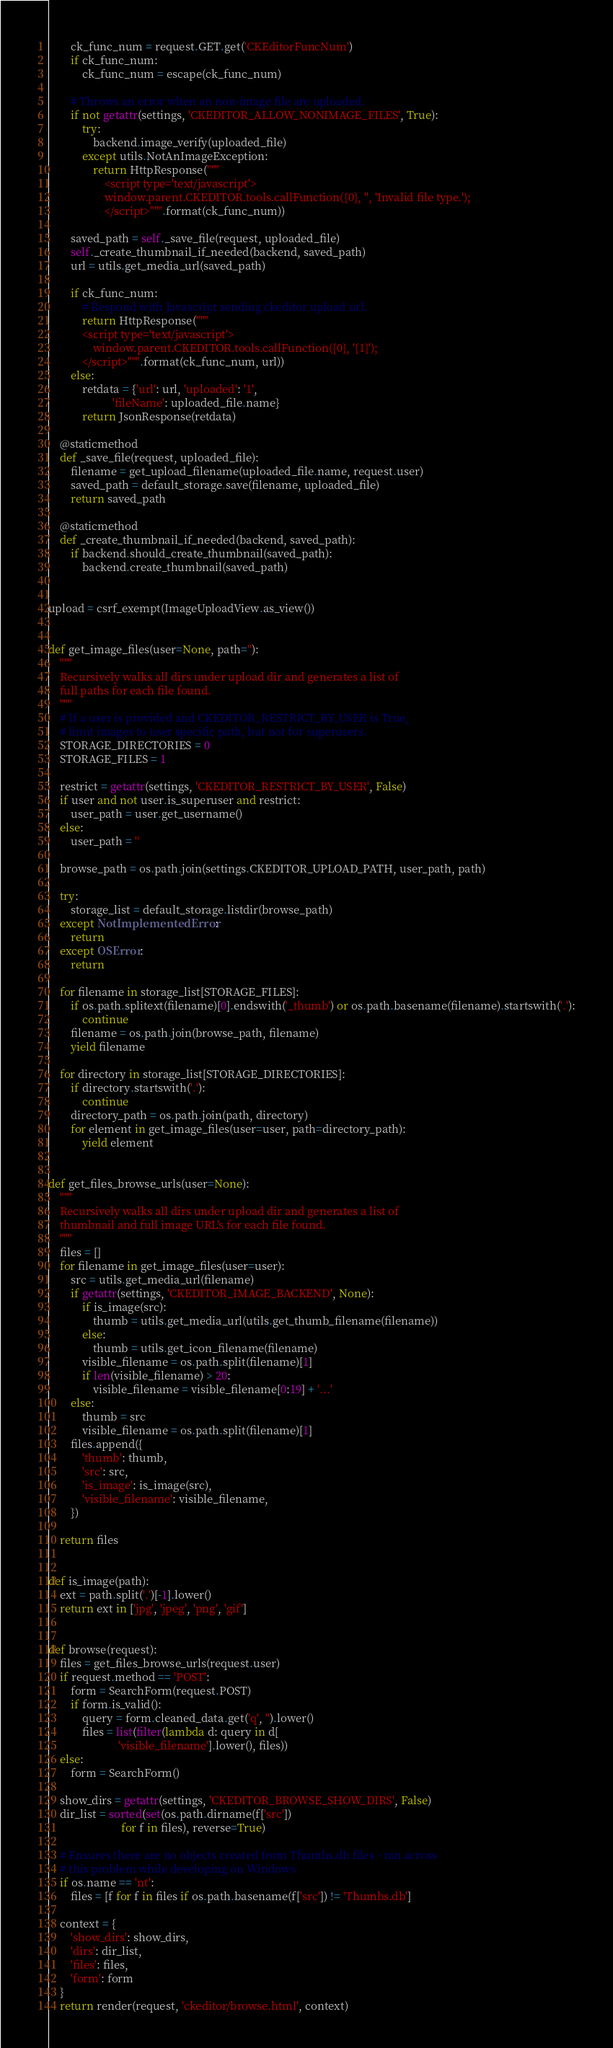Convert code to text. <code><loc_0><loc_0><loc_500><loc_500><_Python_>
        ck_func_num = request.GET.get('CKEditorFuncNum')
        if ck_func_num:
            ck_func_num = escape(ck_func_num)

        # Throws an error when an non-image file are uploaded.
        if not getattr(settings, 'CKEDITOR_ALLOW_NONIMAGE_FILES', True):
            try:
                backend.image_verify(uploaded_file)
            except utils.NotAnImageException:
                return HttpResponse("""
                    <script type='text/javascript'>
                    window.parent.CKEDITOR.tools.callFunction({0}, '', 'Invalid file type.');
                    </script>""".format(ck_func_num))

        saved_path = self._save_file(request, uploaded_file)
        self._create_thumbnail_if_needed(backend, saved_path)
        url = utils.get_media_url(saved_path)

        if ck_func_num:
            # Respond with Javascript sending ckeditor upload url.
            return HttpResponse("""
            <script type='text/javascript'>
                window.parent.CKEDITOR.tools.callFunction({0}, '{1}');
            </script>""".format(ck_func_num, url))
        else:
            retdata = {'url': url, 'uploaded': '1',
                       'fileName': uploaded_file.name}
            return JsonResponse(retdata)

    @staticmethod
    def _save_file(request, uploaded_file):
        filename = get_upload_filename(uploaded_file.name, request.user)
        saved_path = default_storage.save(filename, uploaded_file)
        return saved_path

    @staticmethod
    def _create_thumbnail_if_needed(backend, saved_path):
        if backend.should_create_thumbnail(saved_path):
            backend.create_thumbnail(saved_path)


upload = csrf_exempt(ImageUploadView.as_view())


def get_image_files(user=None, path=''):
    """
    Recursively walks all dirs under upload dir and generates a list of
    full paths for each file found.
    """
    # If a user is provided and CKEDITOR_RESTRICT_BY_USER is True,
    # limit images to user specific path, but not for superusers.
    STORAGE_DIRECTORIES = 0
    STORAGE_FILES = 1

    restrict = getattr(settings, 'CKEDITOR_RESTRICT_BY_USER', False)
    if user and not user.is_superuser and restrict:
        user_path = user.get_username()
    else:
        user_path = ''

    browse_path = os.path.join(settings.CKEDITOR_UPLOAD_PATH, user_path, path)

    try:
        storage_list = default_storage.listdir(browse_path)
    except NotImplementedError:
        return
    except OSError:
        return

    for filename in storage_list[STORAGE_FILES]:
        if os.path.splitext(filename)[0].endswith('_thumb') or os.path.basename(filename).startswith('.'):
            continue
        filename = os.path.join(browse_path, filename)
        yield filename

    for directory in storage_list[STORAGE_DIRECTORIES]:
        if directory.startswith('.'):
            continue
        directory_path = os.path.join(path, directory)
        for element in get_image_files(user=user, path=directory_path):
            yield element


def get_files_browse_urls(user=None):
    """
    Recursively walks all dirs under upload dir and generates a list of
    thumbnail and full image URL's for each file found.
    """
    files = []
    for filename in get_image_files(user=user):
        src = utils.get_media_url(filename)
        if getattr(settings, 'CKEDITOR_IMAGE_BACKEND', None):
            if is_image(src):
                thumb = utils.get_media_url(utils.get_thumb_filename(filename))
            else:
                thumb = utils.get_icon_filename(filename)
            visible_filename = os.path.split(filename)[1]
            if len(visible_filename) > 20:
                visible_filename = visible_filename[0:19] + '...'
        else:
            thumb = src
            visible_filename = os.path.split(filename)[1]
        files.append({
            'thumb': thumb,
            'src': src,
            'is_image': is_image(src),
            'visible_filename': visible_filename,
        })

    return files


def is_image(path):
    ext = path.split('.')[-1].lower()
    return ext in ['jpg', 'jpeg', 'png', 'gif']


def browse(request):
    files = get_files_browse_urls(request.user)
    if request.method == 'POST':
        form = SearchForm(request.POST)
        if form.is_valid():
            query = form.cleaned_data.get('q', '').lower()
            files = list(filter(lambda d: query in d[
                         'visible_filename'].lower(), files))
    else:
        form = SearchForm()

    show_dirs = getattr(settings, 'CKEDITOR_BROWSE_SHOW_DIRS', False)
    dir_list = sorted(set(os.path.dirname(f['src'])
                          for f in files), reverse=True)

    # Ensures there are no objects created from Thumbs.db files - ran across
    # this problem while developing on Windows
    if os.name == 'nt':
        files = [f for f in files if os.path.basename(f['src']) != 'Thumbs.db']

    context = {
        'show_dirs': show_dirs,
        'dirs': dir_list,
        'files': files,
        'form': form
    }
    return render(request, 'ckeditor/browse.html', context)
</code> 